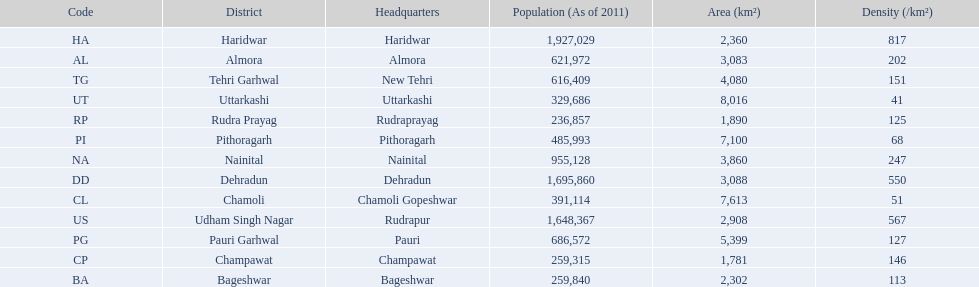If a person was headquartered in almora what would be his/her district? Almora. 